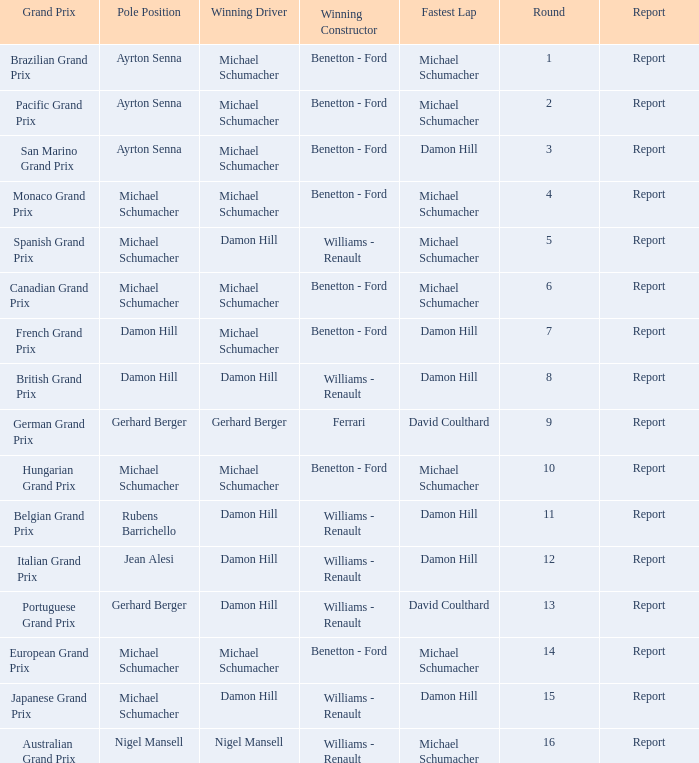Name the lowest round for when pole position and winning driver is michael schumacher 4.0. Could you help me parse every detail presented in this table? {'header': ['Grand Prix', 'Pole Position', 'Winning Driver', 'Winning Constructor', 'Fastest Lap', 'Round', 'Report'], 'rows': [['Brazilian Grand Prix', 'Ayrton Senna', 'Michael Schumacher', 'Benetton - Ford', 'Michael Schumacher', '1', 'Report'], ['Pacific Grand Prix', 'Ayrton Senna', 'Michael Schumacher', 'Benetton - Ford', 'Michael Schumacher', '2', 'Report'], ['San Marino Grand Prix', 'Ayrton Senna', 'Michael Schumacher', 'Benetton - Ford', 'Damon Hill', '3', 'Report'], ['Monaco Grand Prix', 'Michael Schumacher', 'Michael Schumacher', 'Benetton - Ford', 'Michael Schumacher', '4', 'Report'], ['Spanish Grand Prix', 'Michael Schumacher', 'Damon Hill', 'Williams - Renault', 'Michael Schumacher', '5', 'Report'], ['Canadian Grand Prix', 'Michael Schumacher', 'Michael Schumacher', 'Benetton - Ford', 'Michael Schumacher', '6', 'Report'], ['French Grand Prix', 'Damon Hill', 'Michael Schumacher', 'Benetton - Ford', 'Damon Hill', '7', 'Report'], ['British Grand Prix', 'Damon Hill', 'Damon Hill', 'Williams - Renault', 'Damon Hill', '8', 'Report'], ['German Grand Prix', 'Gerhard Berger', 'Gerhard Berger', 'Ferrari', 'David Coulthard', '9', 'Report'], ['Hungarian Grand Prix', 'Michael Schumacher', 'Michael Schumacher', 'Benetton - Ford', 'Michael Schumacher', '10', 'Report'], ['Belgian Grand Prix', 'Rubens Barrichello', 'Damon Hill', 'Williams - Renault', 'Damon Hill', '11', 'Report'], ['Italian Grand Prix', 'Jean Alesi', 'Damon Hill', 'Williams - Renault', 'Damon Hill', '12', 'Report'], ['Portuguese Grand Prix', 'Gerhard Berger', 'Damon Hill', 'Williams - Renault', 'David Coulthard', '13', 'Report'], ['European Grand Prix', 'Michael Schumacher', 'Michael Schumacher', 'Benetton - Ford', 'Michael Schumacher', '14', 'Report'], ['Japanese Grand Prix', 'Michael Schumacher', 'Damon Hill', 'Williams - Renault', 'Damon Hill', '15', 'Report'], ['Australian Grand Prix', 'Nigel Mansell', 'Nigel Mansell', 'Williams - Renault', 'Michael Schumacher', '16', 'Report']]} 